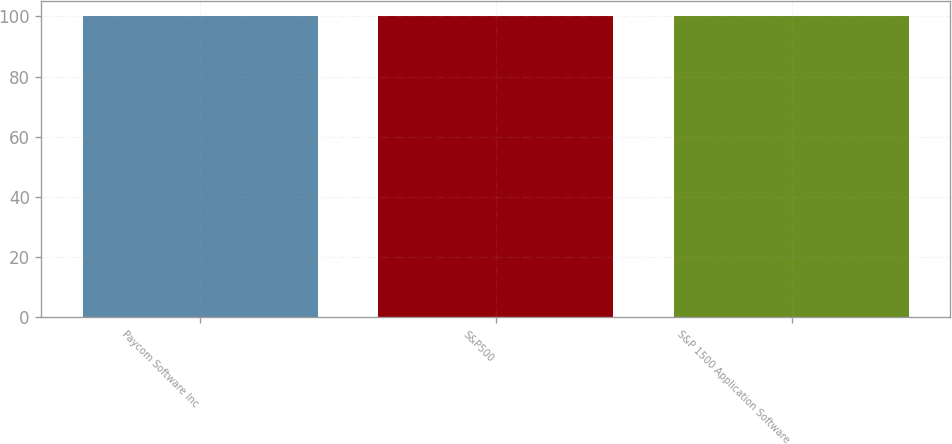Convert chart to OTSL. <chart><loc_0><loc_0><loc_500><loc_500><bar_chart><fcel>Paycom Software Inc<fcel>S&P500<fcel>S&P 1500 Application Software<nl><fcel>100<fcel>100.1<fcel>100.2<nl></chart> 